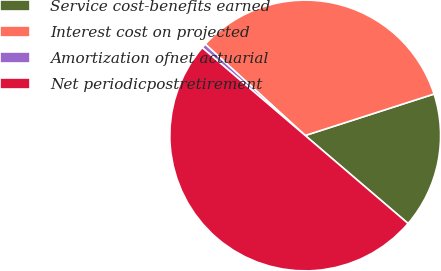Convert chart. <chart><loc_0><loc_0><loc_500><loc_500><pie_chart><fcel>Service cost-benefits earned<fcel>Interest cost on projected<fcel>Amortization ofnet actuarial<fcel>Net periodicpostretirement<nl><fcel>16.22%<fcel>33.26%<fcel>0.54%<fcel>49.98%<nl></chart> 